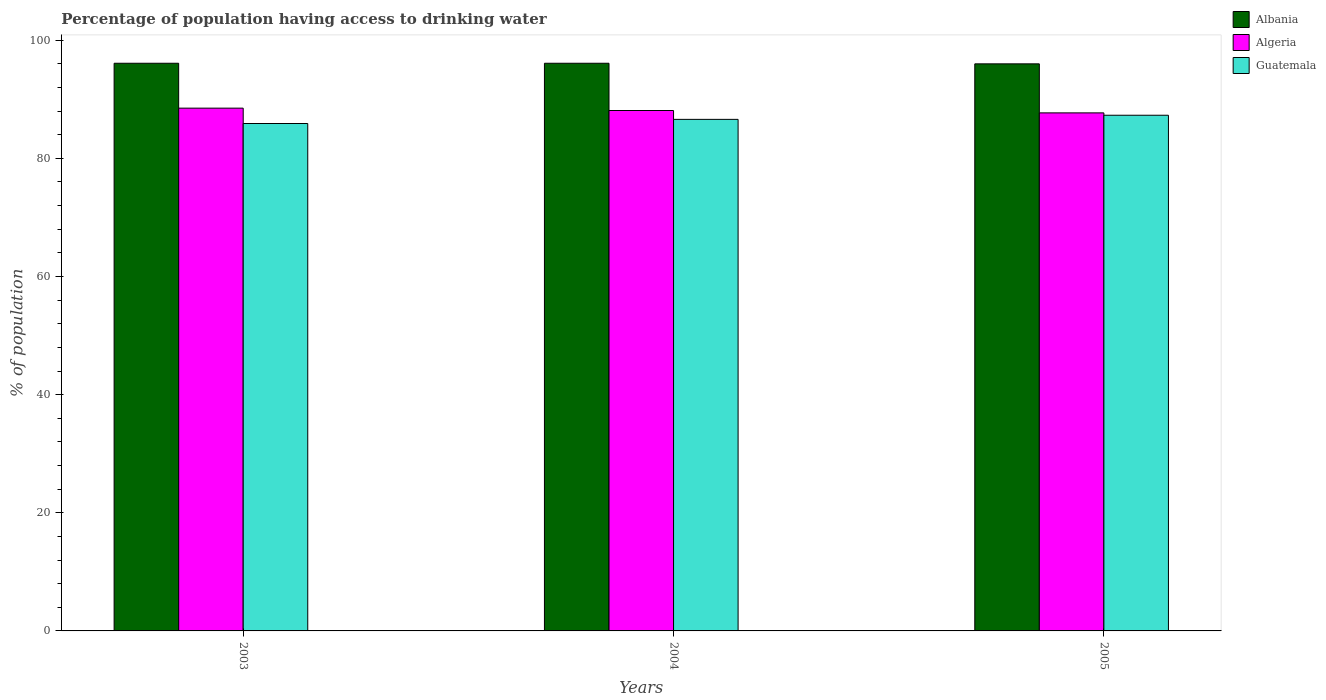How many groups of bars are there?
Offer a very short reply. 3. How many bars are there on the 1st tick from the left?
Give a very brief answer. 3. In how many cases, is the number of bars for a given year not equal to the number of legend labels?
Keep it short and to the point. 0. What is the percentage of population having access to drinking water in Guatemala in 2003?
Ensure brevity in your answer.  85.9. Across all years, what is the maximum percentage of population having access to drinking water in Guatemala?
Offer a very short reply. 87.3. Across all years, what is the minimum percentage of population having access to drinking water in Albania?
Offer a very short reply. 96. In which year was the percentage of population having access to drinking water in Guatemala minimum?
Make the answer very short. 2003. What is the total percentage of population having access to drinking water in Guatemala in the graph?
Offer a terse response. 259.8. What is the difference between the percentage of population having access to drinking water in Algeria in 2004 and that in 2005?
Offer a terse response. 0.4. What is the difference between the percentage of population having access to drinking water in Guatemala in 2003 and the percentage of population having access to drinking water in Albania in 2004?
Your answer should be very brief. -10.2. What is the average percentage of population having access to drinking water in Albania per year?
Your answer should be compact. 96.07. In the year 2004, what is the difference between the percentage of population having access to drinking water in Guatemala and percentage of population having access to drinking water in Albania?
Provide a short and direct response. -9.5. What is the ratio of the percentage of population having access to drinking water in Guatemala in 2004 to that in 2005?
Keep it short and to the point. 0.99. Is the percentage of population having access to drinking water in Algeria in 2004 less than that in 2005?
Provide a short and direct response. No. Is the difference between the percentage of population having access to drinking water in Guatemala in 2004 and 2005 greater than the difference between the percentage of population having access to drinking water in Albania in 2004 and 2005?
Keep it short and to the point. No. What is the difference between the highest and the second highest percentage of population having access to drinking water in Algeria?
Your response must be concise. 0.4. What is the difference between the highest and the lowest percentage of population having access to drinking water in Albania?
Give a very brief answer. 0.1. Is the sum of the percentage of population having access to drinking water in Guatemala in 2003 and 2005 greater than the maximum percentage of population having access to drinking water in Algeria across all years?
Your answer should be compact. Yes. What does the 3rd bar from the left in 2004 represents?
Keep it short and to the point. Guatemala. What does the 1st bar from the right in 2004 represents?
Make the answer very short. Guatemala. Is it the case that in every year, the sum of the percentage of population having access to drinking water in Albania and percentage of population having access to drinking water in Guatemala is greater than the percentage of population having access to drinking water in Algeria?
Give a very brief answer. Yes. How many bars are there?
Provide a succinct answer. 9. Are all the bars in the graph horizontal?
Your answer should be very brief. No. How many years are there in the graph?
Provide a short and direct response. 3. What is the difference between two consecutive major ticks on the Y-axis?
Provide a short and direct response. 20. Are the values on the major ticks of Y-axis written in scientific E-notation?
Your answer should be very brief. No. Does the graph contain any zero values?
Provide a succinct answer. No. Does the graph contain grids?
Offer a terse response. No. What is the title of the graph?
Your response must be concise. Percentage of population having access to drinking water. Does "Cayman Islands" appear as one of the legend labels in the graph?
Your answer should be compact. No. What is the label or title of the Y-axis?
Your answer should be compact. % of population. What is the % of population in Albania in 2003?
Your response must be concise. 96.1. What is the % of population in Algeria in 2003?
Your answer should be compact. 88.5. What is the % of population in Guatemala in 2003?
Offer a terse response. 85.9. What is the % of population of Albania in 2004?
Give a very brief answer. 96.1. What is the % of population of Algeria in 2004?
Your response must be concise. 88.1. What is the % of population in Guatemala in 2004?
Your response must be concise. 86.6. What is the % of population in Albania in 2005?
Offer a terse response. 96. What is the % of population of Algeria in 2005?
Your response must be concise. 87.7. What is the % of population of Guatemala in 2005?
Offer a terse response. 87.3. Across all years, what is the maximum % of population of Albania?
Offer a very short reply. 96.1. Across all years, what is the maximum % of population in Algeria?
Provide a short and direct response. 88.5. Across all years, what is the maximum % of population of Guatemala?
Ensure brevity in your answer.  87.3. Across all years, what is the minimum % of population in Albania?
Give a very brief answer. 96. Across all years, what is the minimum % of population of Algeria?
Offer a very short reply. 87.7. Across all years, what is the minimum % of population of Guatemala?
Provide a short and direct response. 85.9. What is the total % of population in Albania in the graph?
Provide a short and direct response. 288.2. What is the total % of population of Algeria in the graph?
Ensure brevity in your answer.  264.3. What is the total % of population in Guatemala in the graph?
Keep it short and to the point. 259.8. What is the difference between the % of population in Albania in 2003 and that in 2004?
Provide a succinct answer. 0. What is the difference between the % of population of Albania in 2003 and that in 2005?
Your answer should be compact. 0.1. What is the difference between the % of population in Algeria in 2003 and that in 2005?
Ensure brevity in your answer.  0.8. What is the difference between the % of population in Guatemala in 2003 and that in 2005?
Offer a terse response. -1.4. What is the difference between the % of population of Albania in 2004 and that in 2005?
Provide a succinct answer. 0.1. What is the difference between the % of population of Algeria in 2004 and that in 2005?
Offer a very short reply. 0.4. What is the difference between the % of population of Guatemala in 2004 and that in 2005?
Ensure brevity in your answer.  -0.7. What is the difference between the % of population of Albania in 2003 and the % of population of Guatemala in 2004?
Keep it short and to the point. 9.5. What is the difference between the % of population in Algeria in 2003 and the % of population in Guatemala in 2004?
Offer a very short reply. 1.9. What is the difference between the % of population in Albania in 2003 and the % of population in Guatemala in 2005?
Provide a short and direct response. 8.8. What is the average % of population in Albania per year?
Provide a succinct answer. 96.07. What is the average % of population of Algeria per year?
Your answer should be very brief. 88.1. What is the average % of population in Guatemala per year?
Offer a terse response. 86.6. In the year 2003, what is the difference between the % of population in Albania and % of population in Guatemala?
Offer a terse response. 10.2. In the year 2004, what is the difference between the % of population in Algeria and % of population in Guatemala?
Offer a very short reply. 1.5. In the year 2005, what is the difference between the % of population of Albania and % of population of Algeria?
Keep it short and to the point. 8.3. In the year 2005, what is the difference between the % of population in Algeria and % of population in Guatemala?
Give a very brief answer. 0.4. What is the ratio of the % of population in Algeria in 2003 to that in 2004?
Offer a very short reply. 1. What is the ratio of the % of population of Albania in 2003 to that in 2005?
Give a very brief answer. 1. What is the ratio of the % of population in Algeria in 2003 to that in 2005?
Your answer should be very brief. 1.01. What is the ratio of the % of population of Guatemala in 2003 to that in 2005?
Your answer should be compact. 0.98. What is the difference between the highest and the second highest % of population in Albania?
Your answer should be compact. 0. What is the difference between the highest and the second highest % of population in Guatemala?
Offer a terse response. 0.7. What is the difference between the highest and the lowest % of population of Albania?
Ensure brevity in your answer.  0.1. What is the difference between the highest and the lowest % of population in Algeria?
Your answer should be very brief. 0.8. 